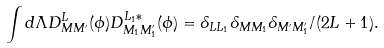<formula> <loc_0><loc_0><loc_500><loc_500>\int d \Lambda D ^ { L } _ { M M ^ { \prime } } ( \phi ) D ^ { L _ { 1 } * } _ { M _ { 1 } M _ { 1 } ^ { \prime } } ( \phi ) = \delta _ { L L _ { 1 } } \delta _ { M M _ { 1 } } \delta _ { M ^ { \prime } M ^ { \prime } _ { 1 } } / ( 2 L + 1 ) .</formula> 